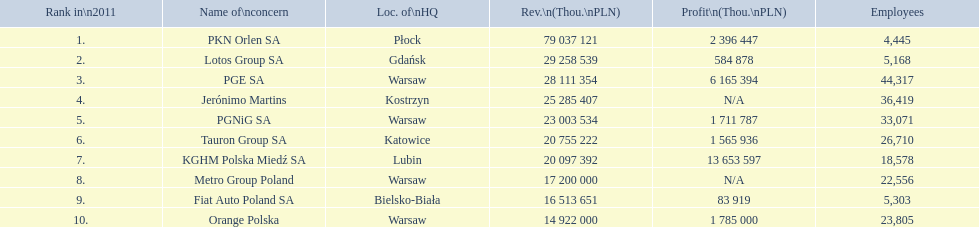What company has 28 111 354 thou.in revenue? PGE SA. What revenue does lotus group sa have? 29 258 539. Who has the next highest revenue than lotus group sa? PKN Orlen SA. 